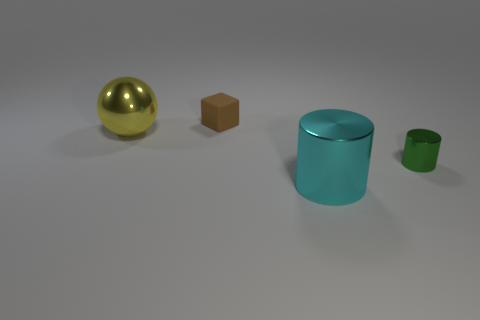How many other objects are the same size as the yellow metal ball?
Your response must be concise. 1. There is a cylinder right of the thing that is in front of the metal cylinder that is on the right side of the cyan cylinder; what is its color?
Your answer should be very brief. Green. How many other things are there of the same shape as the large yellow shiny object?
Offer a terse response. 0. What shape is the small thing that is on the right side of the large metal cylinder?
Ensure brevity in your answer.  Cylinder. There is a tiny object that is in front of the large metallic sphere; are there any small brown objects on the right side of it?
Offer a very short reply. No. The shiny thing that is both on the right side of the rubber block and left of the green shiny cylinder is what color?
Your response must be concise. Cyan. There is a tiny thing that is to the right of the thing that is behind the yellow ball; are there any big spheres that are in front of it?
Provide a short and direct response. No. The other thing that is the same shape as the big cyan object is what size?
Make the answer very short. Small. Is there any other thing that has the same material as the cyan cylinder?
Offer a very short reply. Yes. Is there a big cyan matte cube?
Provide a short and direct response. No. 